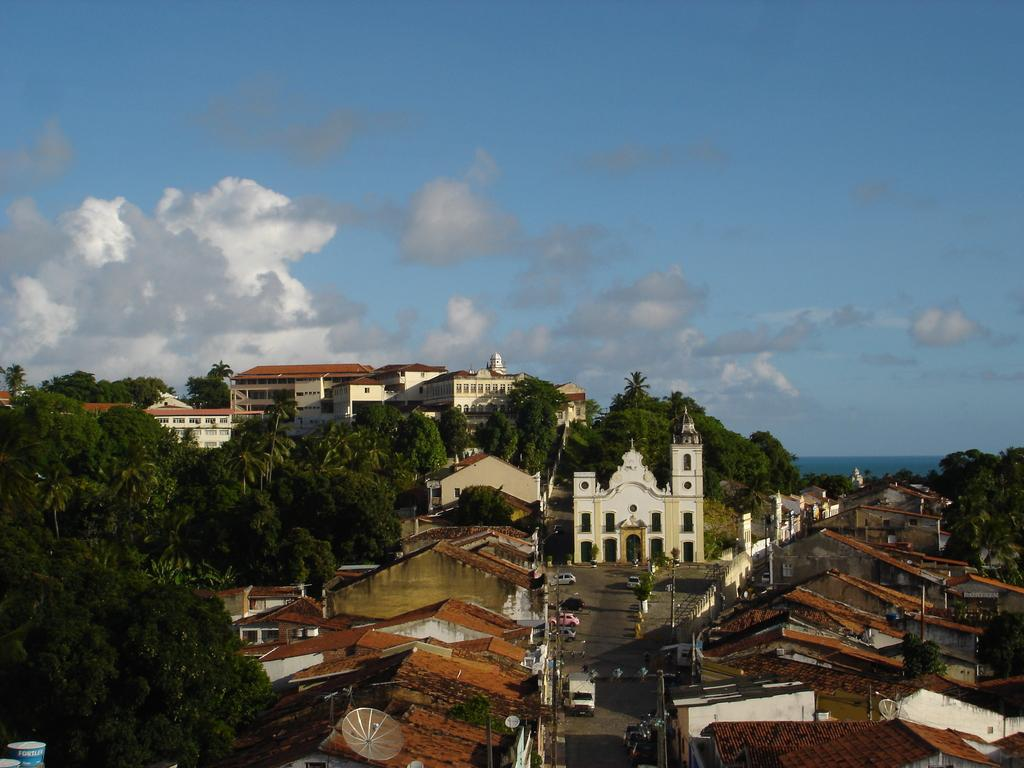What type of structures can be seen in the image? There are houses in the image. What else can be seen besides the houses? There are poles and vehicles visible in the image. What can be seen in the background of the image? There are trees, buildings, and clouds in the background of the image. How many rods are being used by the laborer in the image? There is no laborer or rod present in the image. What type of heart can be seen beating in the image? There is no heart visible in the image. 